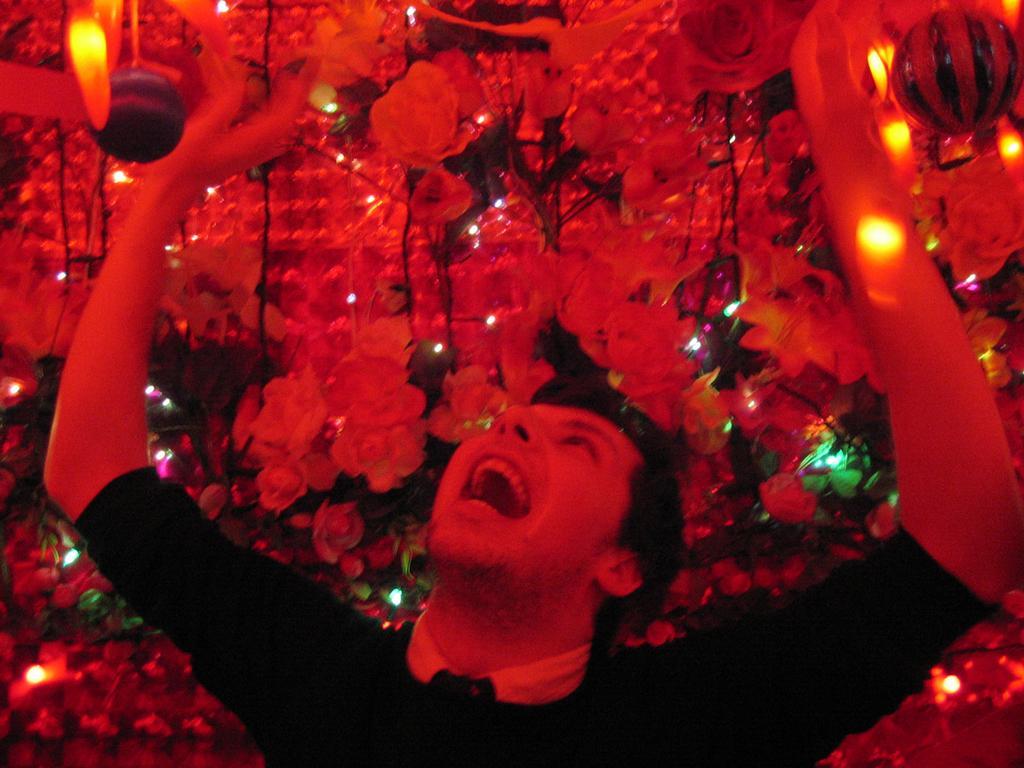Describe this image in one or two sentences. In this image we can see a person. There are many artificial flowers and plants in the image. There are few lights in the image. 